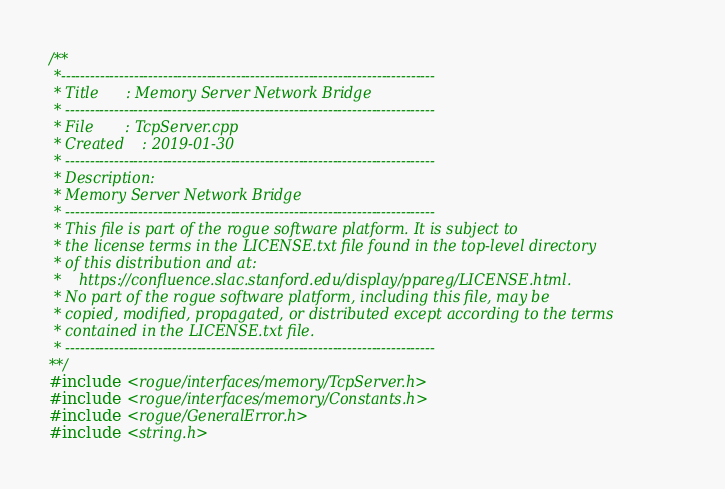<code> <loc_0><loc_0><loc_500><loc_500><_C++_>/**
 *-----------------------------------------------------------------------------
 * Title      : Memory Server Network Bridge
 * ----------------------------------------------------------------------------
 * File       : TcpServer.cpp
 * Created    : 2019-01-30
 * ----------------------------------------------------------------------------
 * Description:
 * Memory Server Network Bridge
 * ----------------------------------------------------------------------------
 * This file is part of the rogue software platform. It is subject to
 * the license terms in the LICENSE.txt file found in the top-level directory
 * of this distribution and at:
 *    https://confluence.slac.stanford.edu/display/ppareg/LICENSE.html.
 * No part of the rogue software platform, including this file, may be
 * copied, modified, propagated, or distributed except according to the terms
 * contained in the LICENSE.txt file.
 * ----------------------------------------------------------------------------
**/
#include <rogue/interfaces/memory/TcpServer.h>
#include <rogue/interfaces/memory/Constants.h>
#include <rogue/GeneralError.h>
#include <string.h></code> 